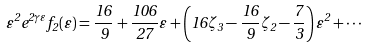<formula> <loc_0><loc_0><loc_500><loc_500>\varepsilon ^ { 2 } e ^ { 2 \gamma \varepsilon } f _ { 2 } ( \varepsilon ) = \frac { 1 6 } { 9 } + \frac { 1 0 6 } { 2 7 } \varepsilon + \left ( 1 6 \zeta _ { 3 } - \frac { 1 6 } { 9 } \zeta _ { 2 } - \frac { 7 } { 3 } \right ) \varepsilon ^ { 2 } + \cdots</formula> 